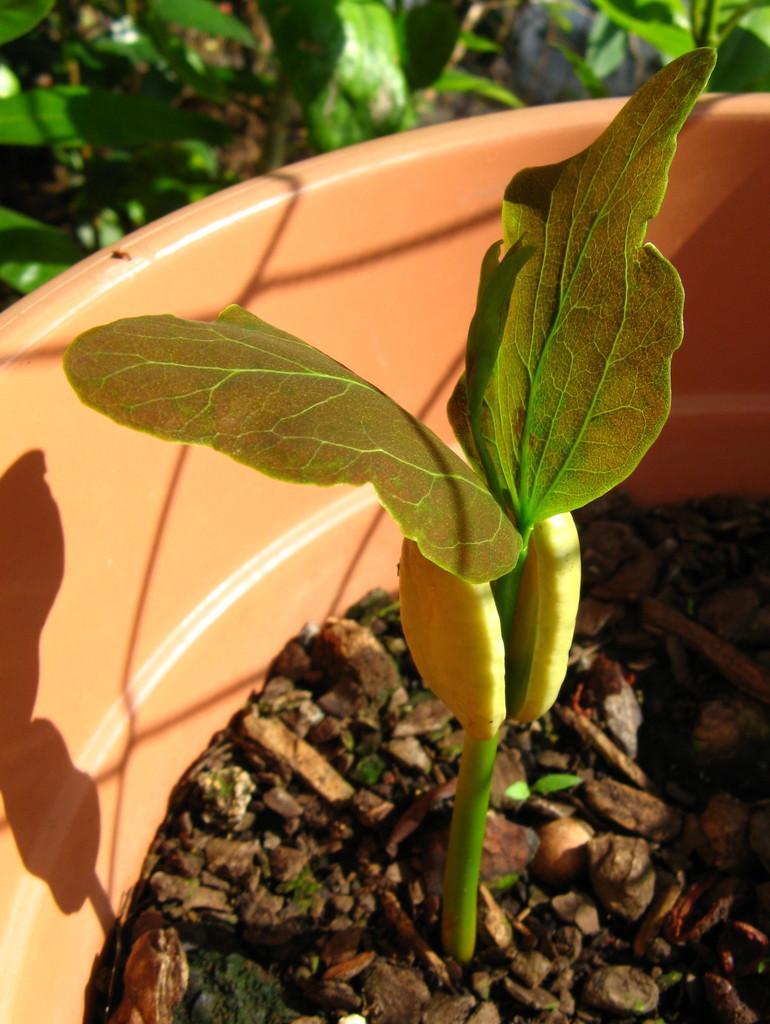How would you summarize this image in a sentence or two? In this picture I can see a pot in front, in which I can see brown color things and a plant. In the background I can see few more plants. 